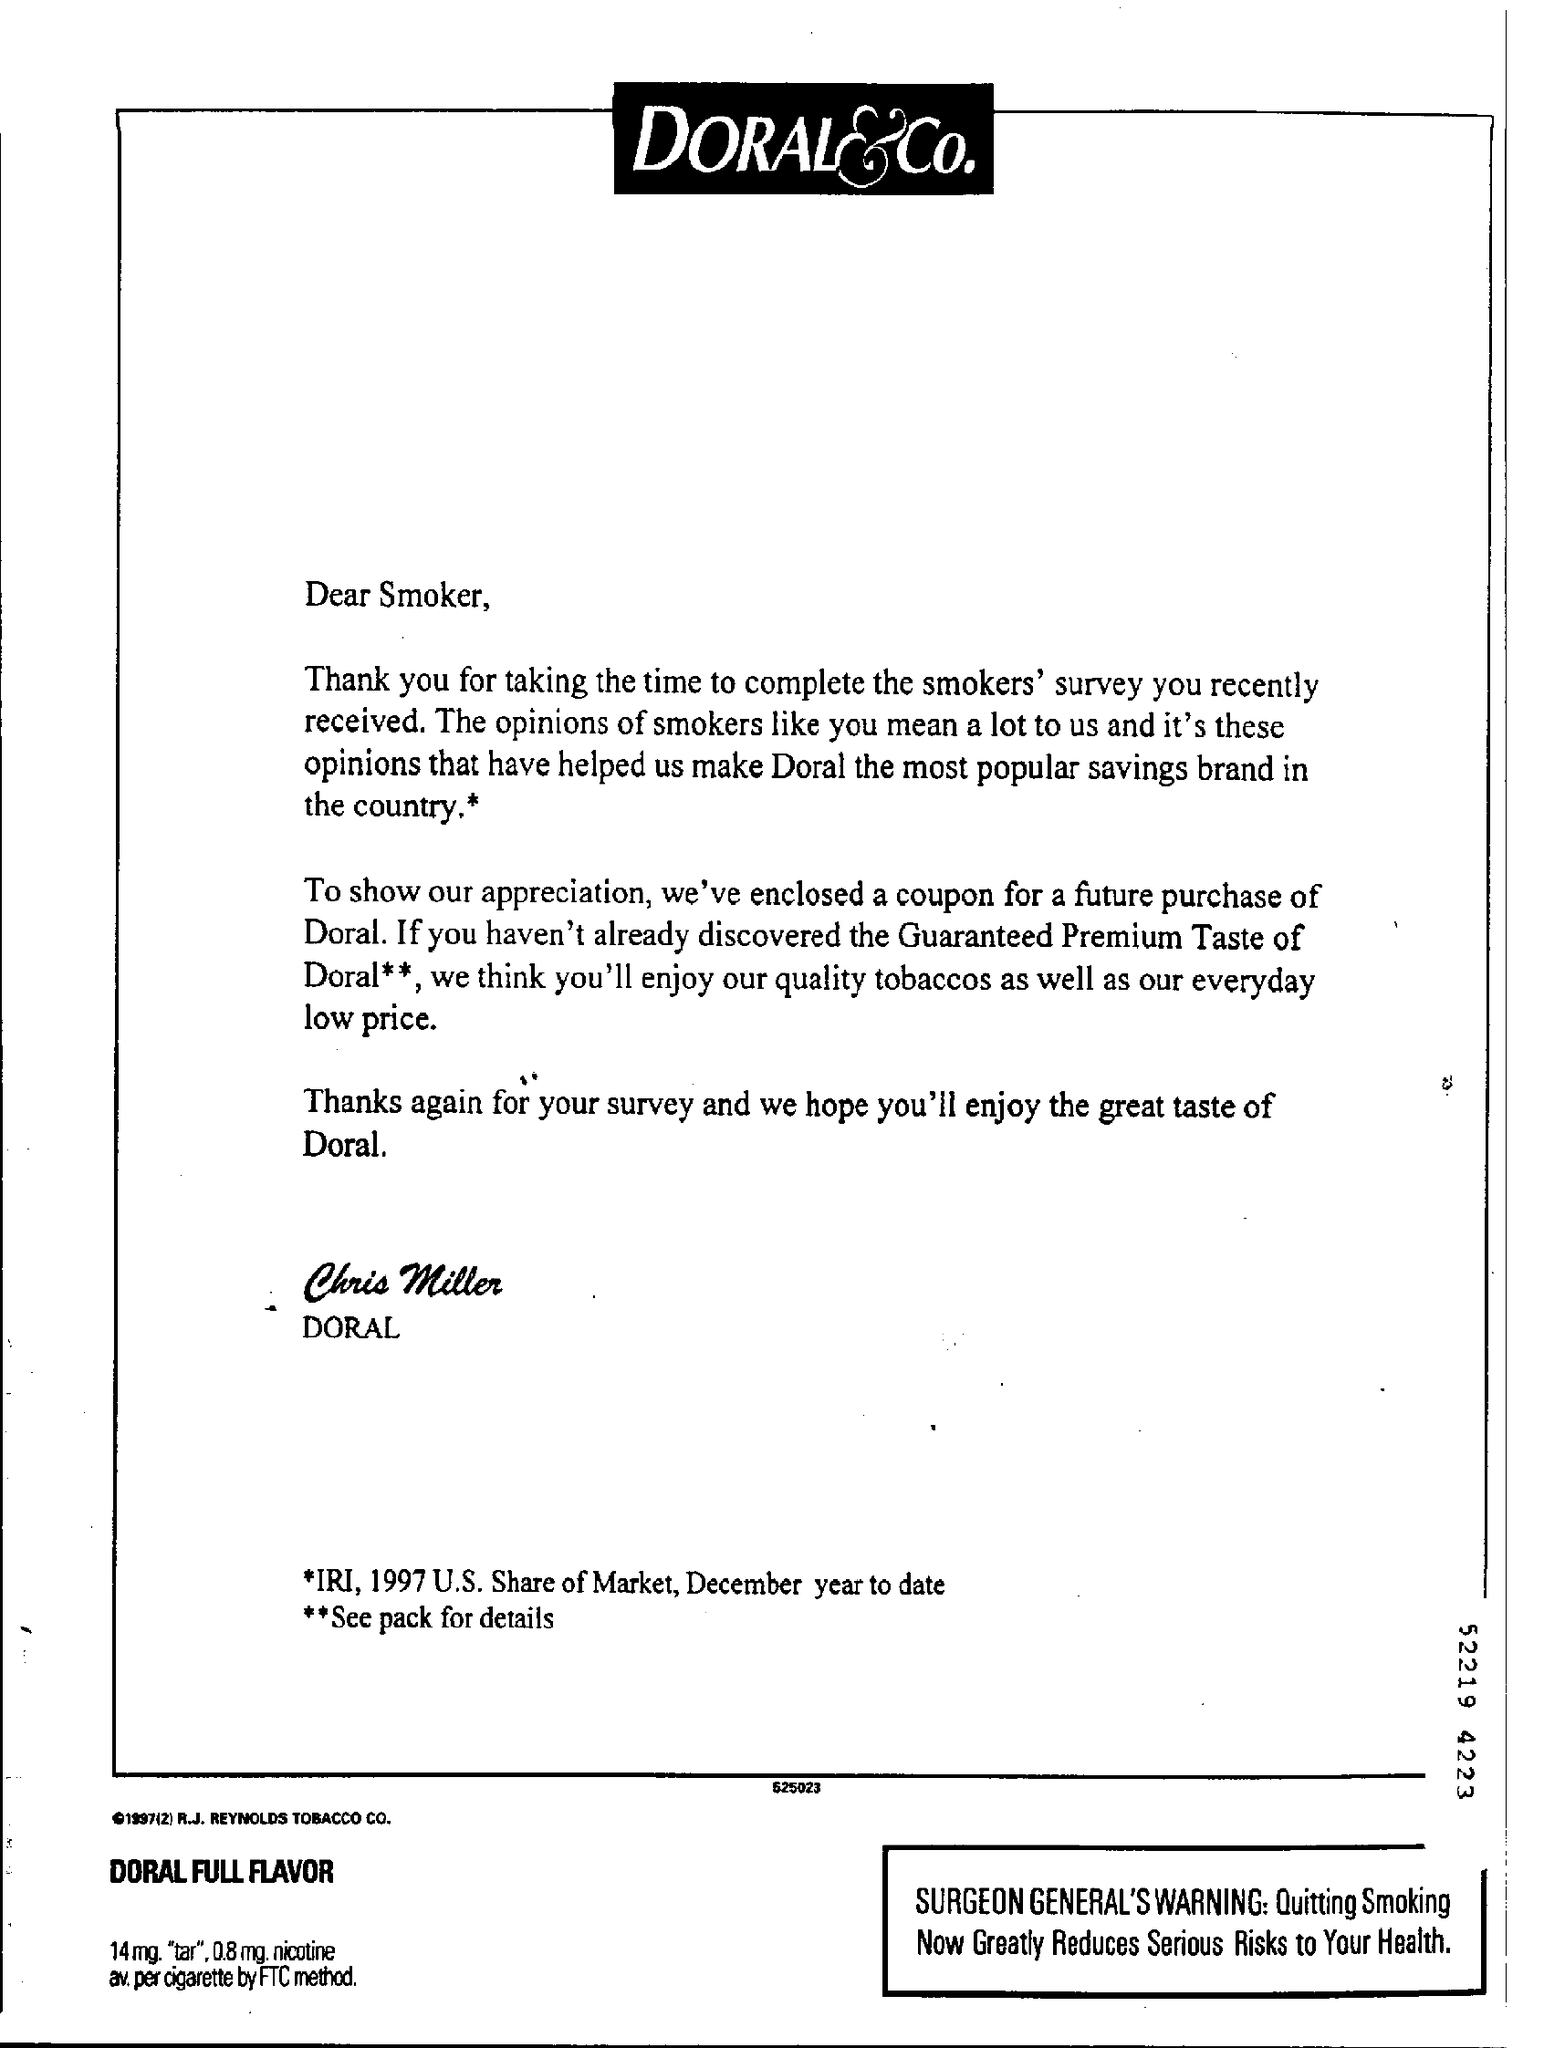Who is the author of this letter?
Your response must be concise. Chris Miller. 